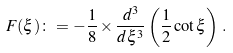Convert formula to latex. <formula><loc_0><loc_0><loc_500><loc_500>F ( \xi ) \colon = - \frac { 1 } { 8 } \times { \frac { d ^ { 3 } } { d \xi ^ { 3 } } } \left ( { \frac { 1 } { 2 } } \cot { \xi } \right ) \, .</formula> 